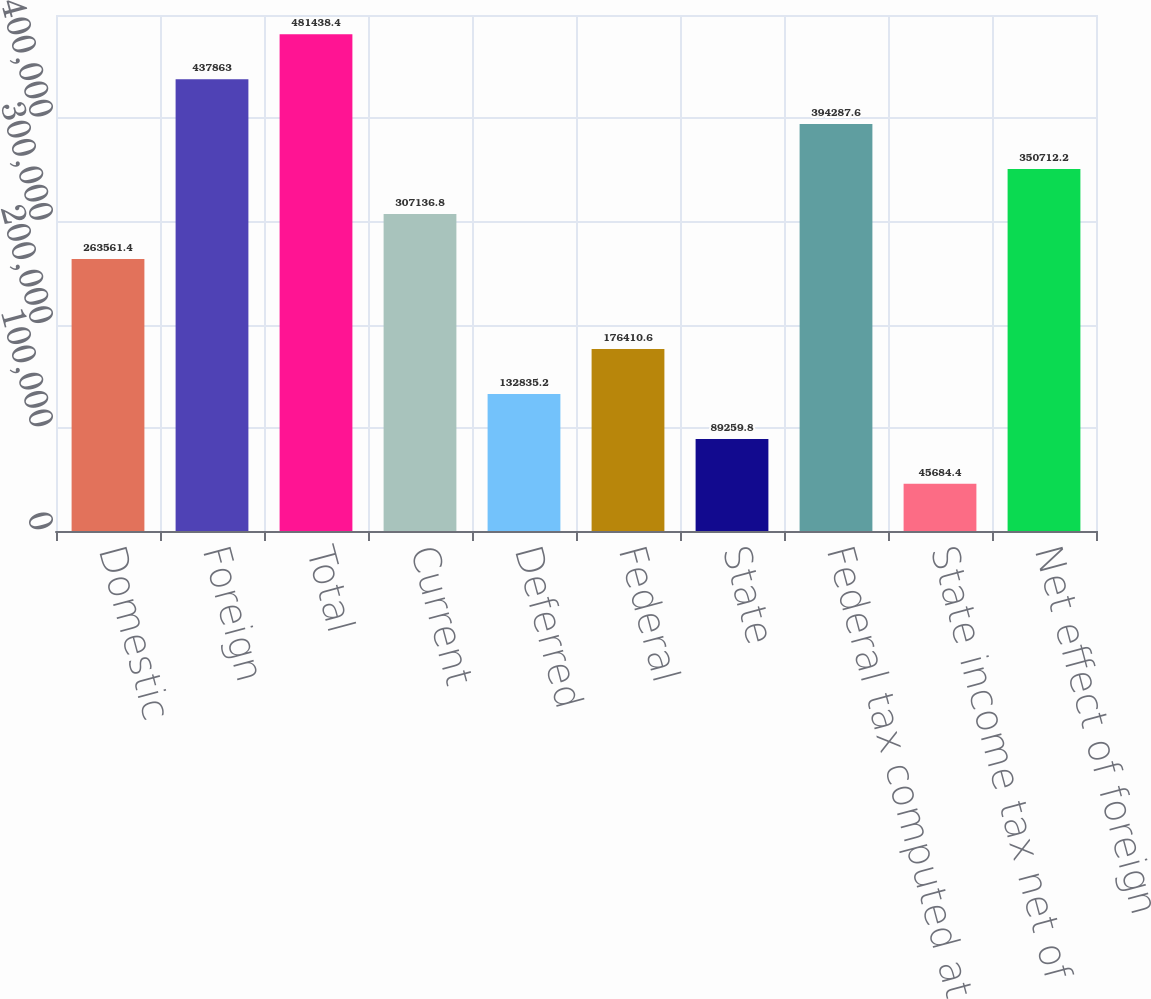Convert chart to OTSL. <chart><loc_0><loc_0><loc_500><loc_500><bar_chart><fcel>Domestic<fcel>Foreign<fcel>Total<fcel>Current<fcel>Deferred<fcel>Federal<fcel>State<fcel>Federal tax computed at US<fcel>State income tax net of<fcel>Net effect of foreign<nl><fcel>263561<fcel>437863<fcel>481438<fcel>307137<fcel>132835<fcel>176411<fcel>89259.8<fcel>394288<fcel>45684.4<fcel>350712<nl></chart> 